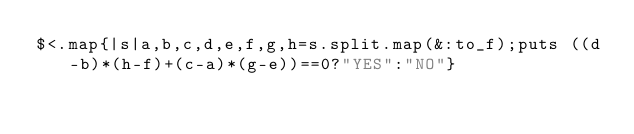<code> <loc_0><loc_0><loc_500><loc_500><_Ruby_>$<.map{|s|a,b,c,d,e,f,g,h=s.split.map(&:to_f);puts ((d-b)*(h-f)+(c-a)*(g-e))==0?"YES":"NO"}</code> 